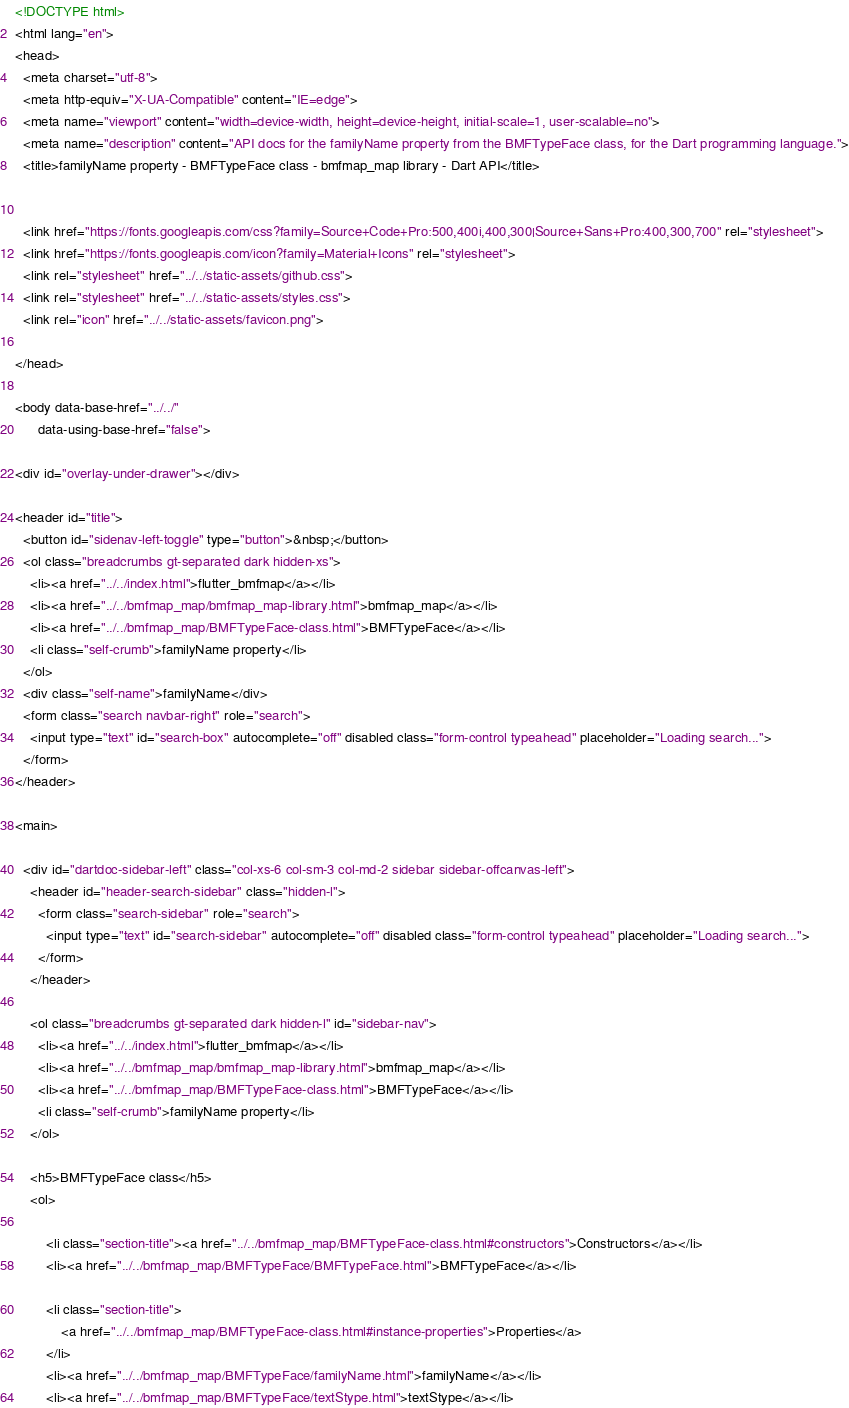<code> <loc_0><loc_0><loc_500><loc_500><_HTML_><!DOCTYPE html>
<html lang="en">
<head>
  <meta charset="utf-8">
  <meta http-equiv="X-UA-Compatible" content="IE=edge">
  <meta name="viewport" content="width=device-width, height=device-height, initial-scale=1, user-scalable=no">
  <meta name="description" content="API docs for the familyName property from the BMFTypeFace class, for the Dart programming language.">
  <title>familyName property - BMFTypeFace class - bmfmap_map library - Dart API</title>

  
  <link href="https://fonts.googleapis.com/css?family=Source+Code+Pro:500,400i,400,300|Source+Sans+Pro:400,300,700" rel="stylesheet">
  <link href="https://fonts.googleapis.com/icon?family=Material+Icons" rel="stylesheet">
  <link rel="stylesheet" href="../../static-assets/github.css">
  <link rel="stylesheet" href="../../static-assets/styles.css">
  <link rel="icon" href="../../static-assets/favicon.png">

</head>

<body data-base-href="../../"
      data-using-base-href="false">

<div id="overlay-under-drawer"></div>

<header id="title">
  <button id="sidenav-left-toggle" type="button">&nbsp;</button>
  <ol class="breadcrumbs gt-separated dark hidden-xs">
    <li><a href="../../index.html">flutter_bmfmap</a></li>
    <li><a href="../../bmfmap_map/bmfmap_map-library.html">bmfmap_map</a></li>
    <li><a href="../../bmfmap_map/BMFTypeFace-class.html">BMFTypeFace</a></li>
    <li class="self-crumb">familyName property</li>
  </ol>
  <div class="self-name">familyName</div>
  <form class="search navbar-right" role="search">
    <input type="text" id="search-box" autocomplete="off" disabled class="form-control typeahead" placeholder="Loading search...">
  </form>
</header>

<main>

  <div id="dartdoc-sidebar-left" class="col-xs-6 col-sm-3 col-md-2 sidebar sidebar-offcanvas-left">
    <header id="header-search-sidebar" class="hidden-l">
      <form class="search-sidebar" role="search">
        <input type="text" id="search-sidebar" autocomplete="off" disabled class="form-control typeahead" placeholder="Loading search...">
      </form>
    </header>
    
    <ol class="breadcrumbs gt-separated dark hidden-l" id="sidebar-nav">
      <li><a href="../../index.html">flutter_bmfmap</a></li>
      <li><a href="../../bmfmap_map/bmfmap_map-library.html">bmfmap_map</a></li>
      <li><a href="../../bmfmap_map/BMFTypeFace-class.html">BMFTypeFace</a></li>
      <li class="self-crumb">familyName property</li>
    </ol>
    
    <h5>BMFTypeFace class</h5>
    <ol>
    
        <li class="section-title"><a href="../../bmfmap_map/BMFTypeFace-class.html#constructors">Constructors</a></li>
        <li><a href="../../bmfmap_map/BMFTypeFace/BMFTypeFace.html">BMFTypeFace</a></li>
    
        <li class="section-title">
            <a href="../../bmfmap_map/BMFTypeFace-class.html#instance-properties">Properties</a>
        </li>
        <li><a href="../../bmfmap_map/BMFTypeFace/familyName.html">familyName</a></li>
        <li><a href="../../bmfmap_map/BMFTypeFace/textStype.html">textStype</a></li></code> 